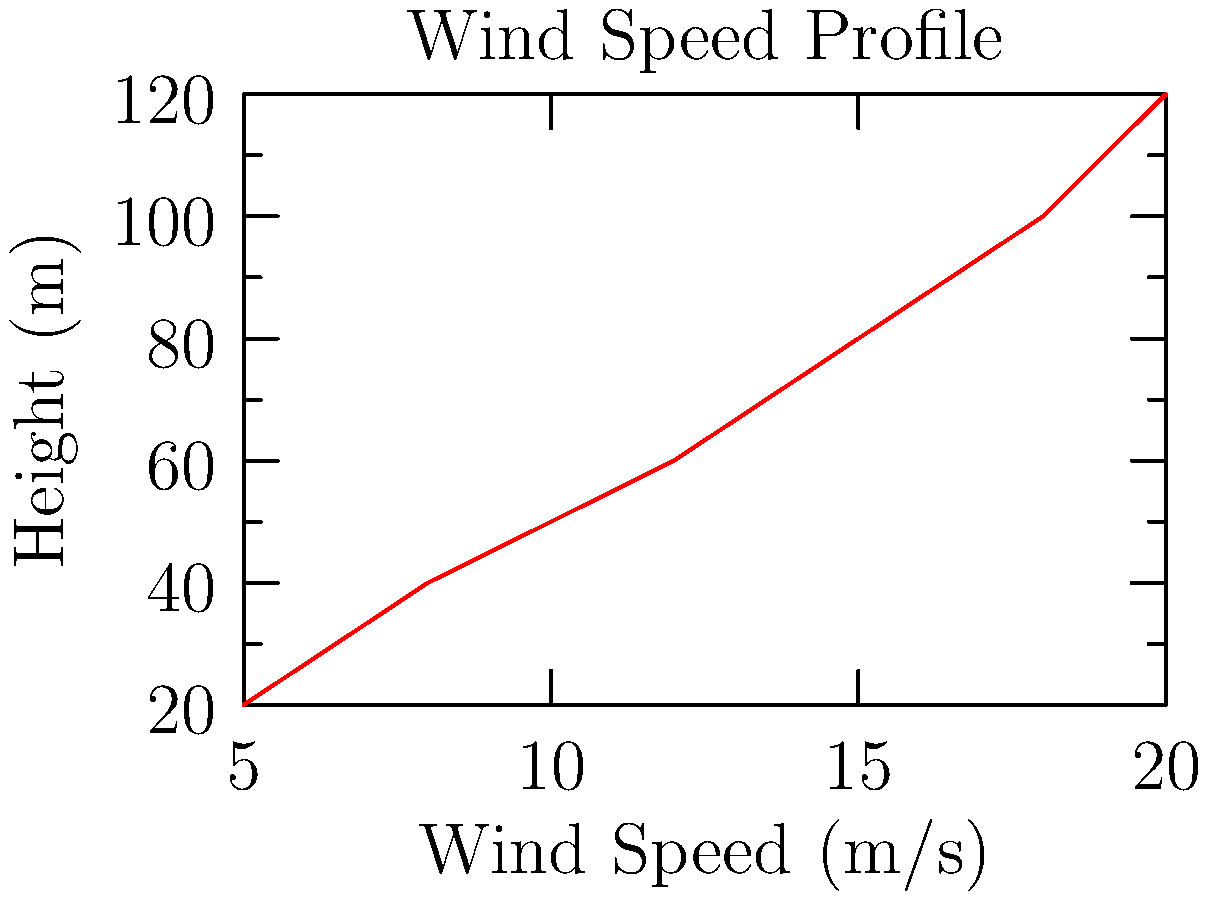Given the wind speed profile shown in the graph for a potential wind farm site in Pennsylvania, estimate the wind load on a turbine tower with a height of 100 m and a rotor diameter of 90 m. Assume the drag coefficient $C_d = 1.2$ and air density $\rho = 1.225 \, \text{kg}/\text{m}^3$. Use the equation $F = \frac{1}{2} \rho v^2 A C_d$, where $v$ is the wind speed at hub height and $A$ is the swept area of the rotor. Round your answer to the nearest kN. To solve this problem, we'll follow these steps:

1. Determine the wind speed at hub height (100 m) from the graph:
   At 100 m, the wind speed is approximately 18 m/s.

2. Calculate the swept area of the rotor:
   $A = \pi r^2 = \pi (45 \, \text{m})^2 = 6,361.73 \, \text{m}^2$

3. Apply the wind load equation:
   $F = \frac{1}{2} \rho v^2 A C_d$

   Where:
   $\rho = 1.225 \, \text{kg}/\text{m}^3$
   $v = 18 \, \text{m}/\text{s}$
   $A = 6,361.73 \, \text{m}^2$
   $C_d = 1.2$

4. Calculate the wind load:
   $F = \frac{1}{2} (1.225)(18^2)(6,361.73)(1.2)$
   $F = 1,499,679.51 \, \text{N}$

5. Convert to kN and round to the nearest whole number:
   $F = 1,499.68 \, \text{kN} \approx 1,500 \, \text{kN}$
Answer: 1,500 kN 